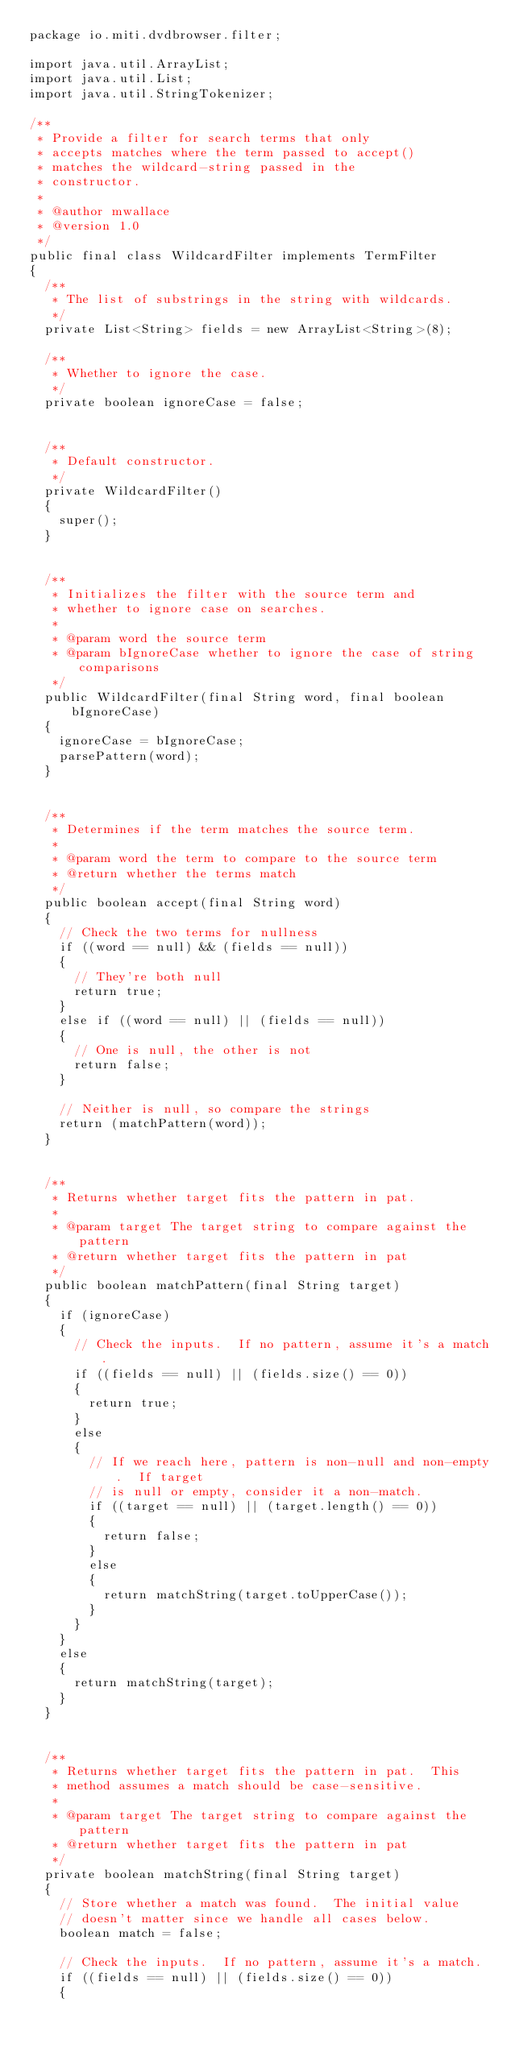<code> <loc_0><loc_0><loc_500><loc_500><_Java_>package io.miti.dvdbrowser.filter;

import java.util.ArrayList;
import java.util.List;
import java.util.StringTokenizer;

/**
 * Provide a filter for search terms that only
 * accepts matches where the term passed to accept()
 * matches the wildcard-string passed in the
 * constructor.
 * 
 * @author mwallace
 * @version 1.0
 */
public final class WildcardFilter implements TermFilter
{
  /**
   * The list of substrings in the string with wildcards.
   */
  private List<String> fields = new ArrayList<String>(8);
  
  /**
   * Whether to ignore the case.
   */
  private boolean ignoreCase = false;
  
  
  /**
   * Default constructor.
   */
  private WildcardFilter()
  {
    super();
  }
  
  
  /**
   * Initializes the filter with the source term and
   * whether to ignore case on searches.
   * 
   * @param word the source term
   * @param bIgnoreCase whether to ignore the case of string comparisons
   */
  public WildcardFilter(final String word, final boolean bIgnoreCase)
  {
    ignoreCase = bIgnoreCase;
    parsePattern(word);
  }
  
  
  /**
   * Determines if the term matches the source term.
   * 
   * @param word the term to compare to the source term
   * @return whether the terms match
   */
  public boolean accept(final String word)
  {
    // Check the two terms for nullness
    if ((word == null) && (fields == null))
    {
      // They're both null
      return true;
    }
    else if ((word == null) || (fields == null))
    {
      // One is null, the other is not
      return false;
    }
    
    // Neither is null, so compare the strings
    return (matchPattern(word));
  }
  
  
  /**
   * Returns whether target fits the pattern in pat.
   *
   * @param target The target string to compare against the pattern
   * @return whether target fits the pattern in pat
   */
  public boolean matchPattern(final String target)
  {
    if (ignoreCase)
    {
      // Check the inputs.  If no pattern, assume it's a match.
      if ((fields == null) || (fields.size() == 0))
      {
        return true;
      }
      else
      {
        // If we reach here, pattern is non-null and non-empty.  If target
        // is null or empty, consider it a non-match.
        if ((target == null) || (target.length() == 0))
        {
          return false;
        }
        else
        {
          return matchString(target.toUpperCase());
        }
      }
    }
    else
    {
      return matchString(target);
    }
  }
  
  
  /**
   * Returns whether target fits the pattern in pat.  This
   * method assumes a match should be case-sensitive.
   *
   * @param target The target string to compare against the pattern
   * @return whether target fits the pattern in pat
   */
  private boolean matchString(final String target)
  {
    // Store whether a match was found.  The initial value
    // doesn't matter since we handle all cases below.
    boolean match = false;
    
    // Check the inputs.  If no pattern, assume it's a match.
    if ((fields == null) || (fields.size() == 0))
    {</code> 